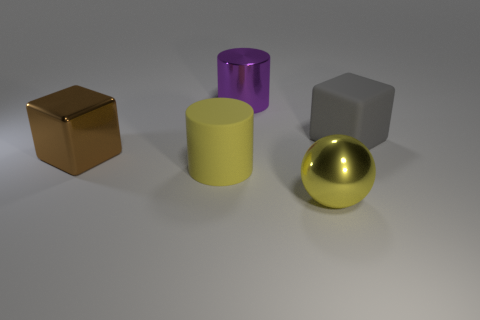Add 3 large yellow cylinders. How many objects exist? 8 Subtract all cylinders. How many objects are left? 3 Add 4 large blocks. How many large blocks exist? 6 Subtract 0 red cylinders. How many objects are left? 5 Subtract all large purple shiny objects. Subtract all cylinders. How many objects are left? 2 Add 3 large balls. How many large balls are left? 4 